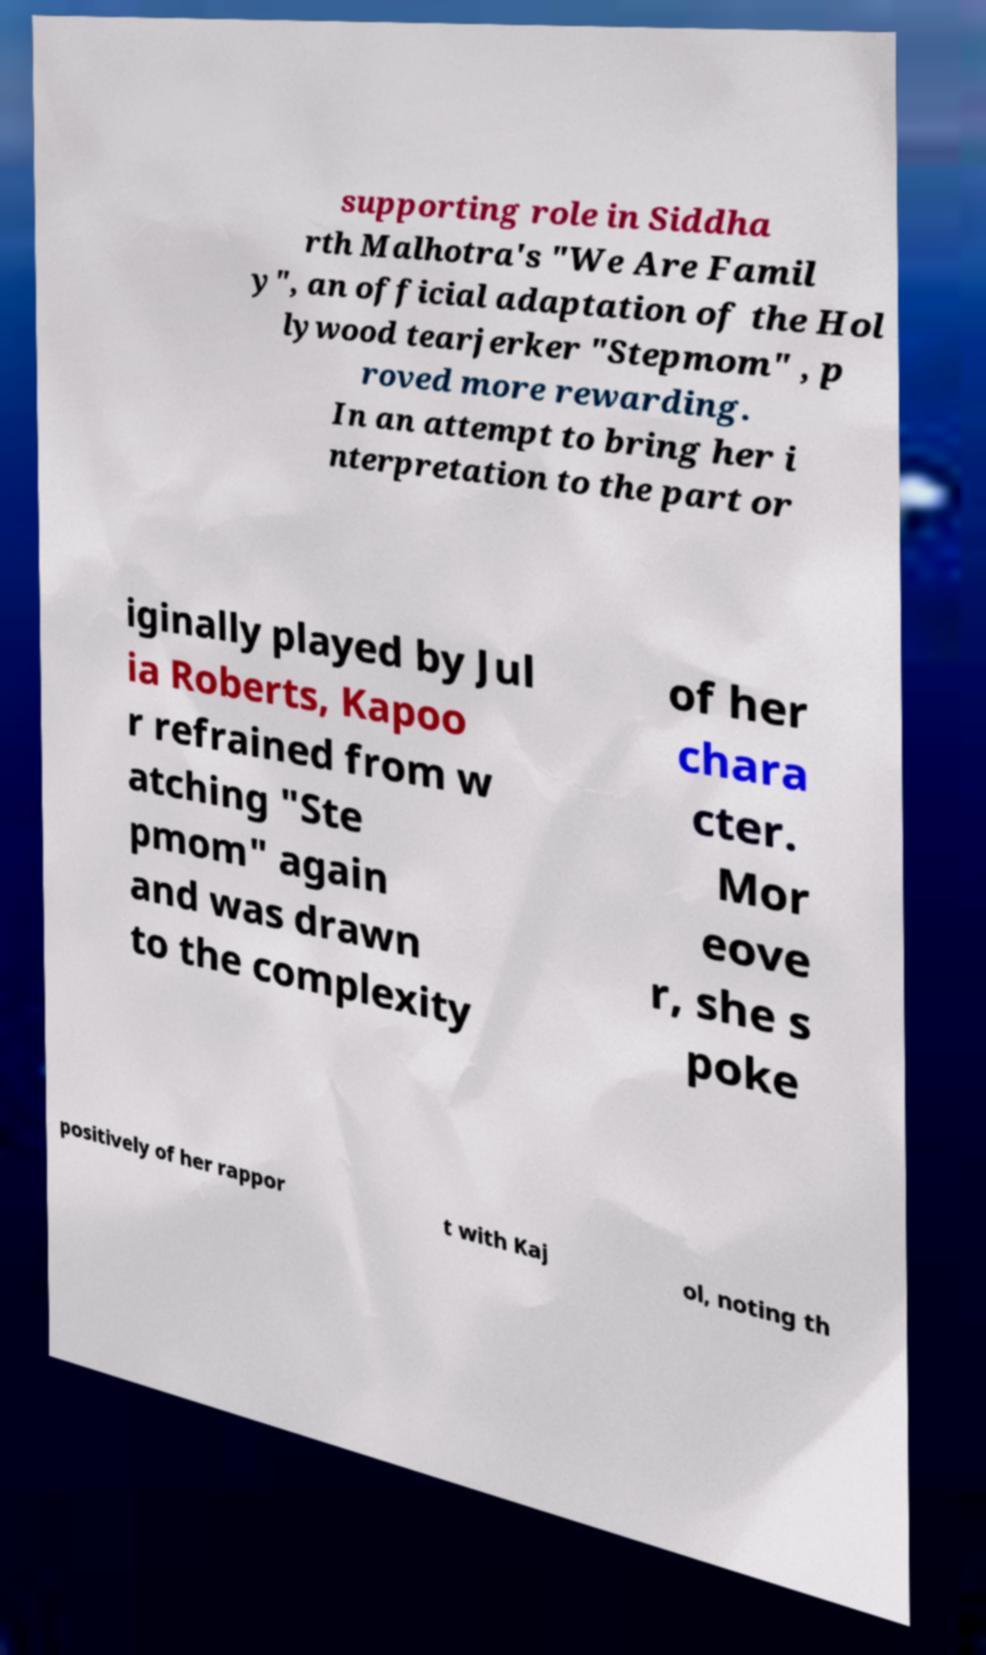Can you read and provide the text displayed in the image?This photo seems to have some interesting text. Can you extract and type it out for me? supporting role in Siddha rth Malhotra's "We Are Famil y", an official adaptation of the Hol lywood tearjerker "Stepmom" , p roved more rewarding. In an attempt to bring her i nterpretation to the part or iginally played by Jul ia Roberts, Kapoo r refrained from w atching "Ste pmom" again and was drawn to the complexity of her chara cter. Mor eove r, she s poke positively of her rappor t with Kaj ol, noting th 